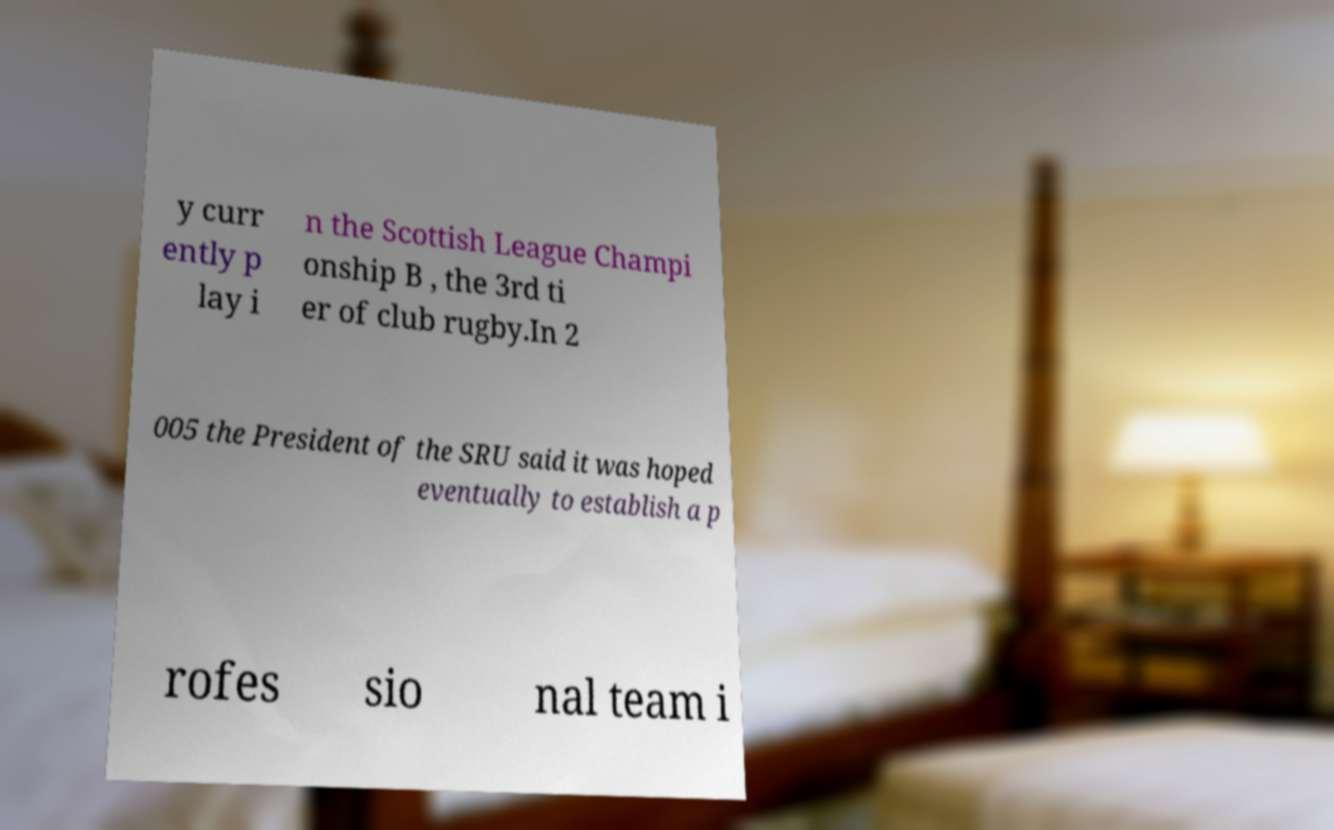For documentation purposes, I need the text within this image transcribed. Could you provide that? y curr ently p lay i n the Scottish League Champi onship B , the 3rd ti er of club rugby.In 2 005 the President of the SRU said it was hoped eventually to establish a p rofes sio nal team i 